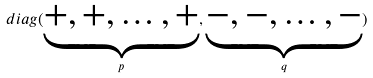<formula> <loc_0><loc_0><loc_500><loc_500>d i a g ( \underbrace { + , + , \dots , + } _ { p } , \underbrace { - , - , \dots , - } _ { q } )</formula> 